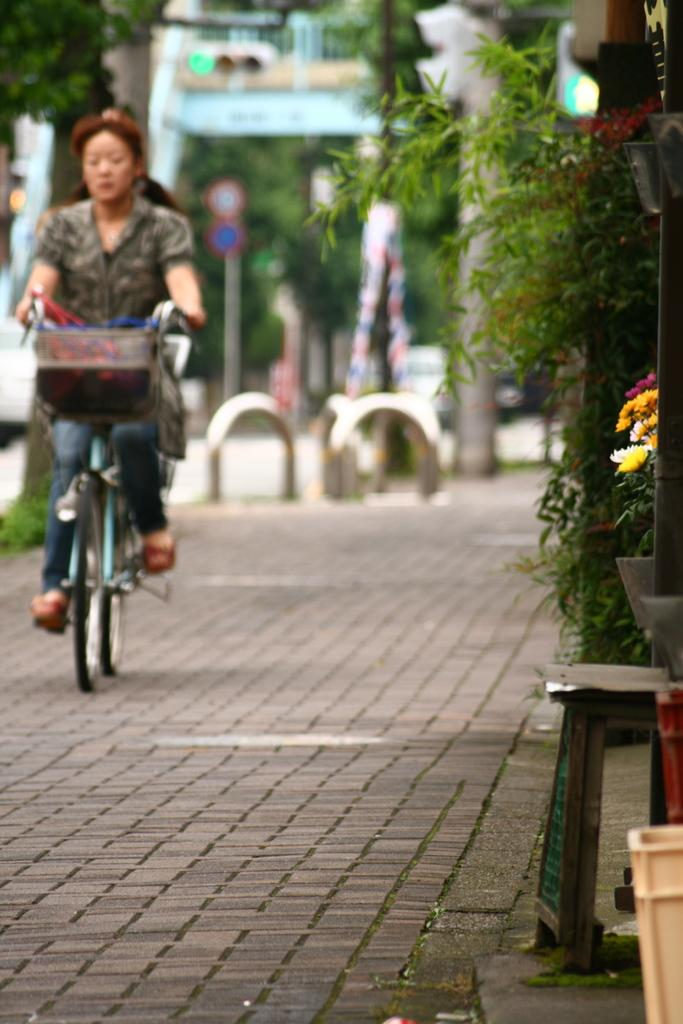Who is the main subject in the image? There is a lady in the image. What is the lady doing in the image? The lady is riding a bicycle. Where is the bicycle located in the image? The bicycle is on the road. What can be seen on the right side of the image? There are plants visible on the right side of the image. What type of tomatoes can be seen growing on the bicycle in the image? There are no tomatoes present in the image, and the bicycle is not a place where plants would typically grow. 